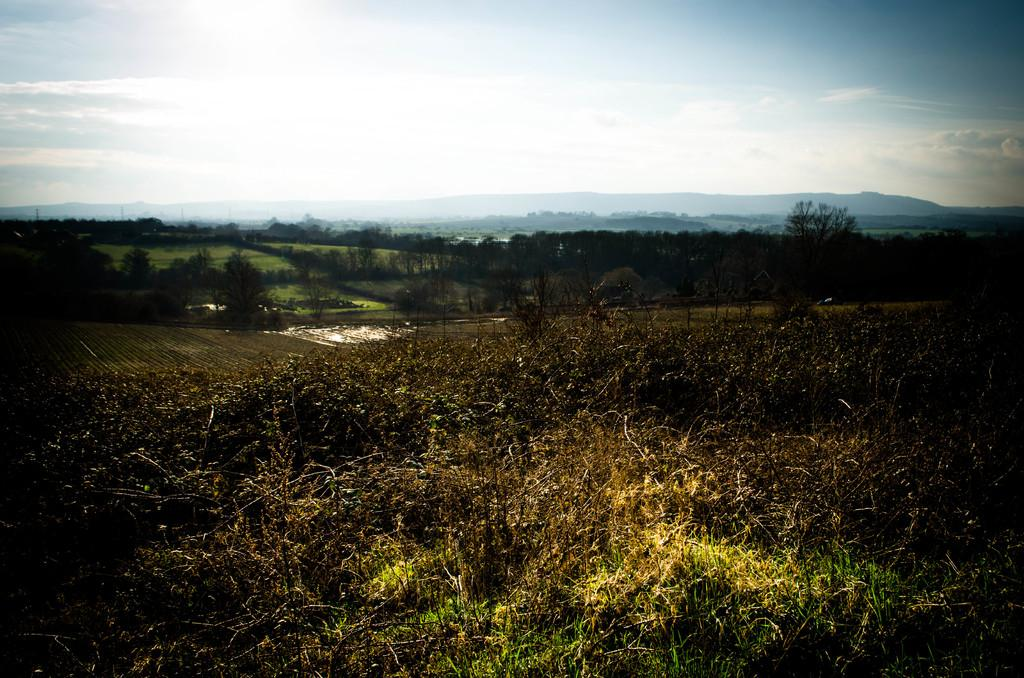What type of vegetation is present in the image? There is grass in the image. What other natural elements can be seen in the image? There are trees in the image. What geographical features are visible in the image? There are hills in the image. What is visible in the background of the image? The sky is visible in the background of the image. Can you see a heart-shaped formation in the grass in the image? There is no heart-shaped formation visible in the grass in the image. Is there a volcano erupting in the background of the image? There is no volcano present in the image. Can you spot a tiger walking among the trees in the image? There is no tiger present in the image. 